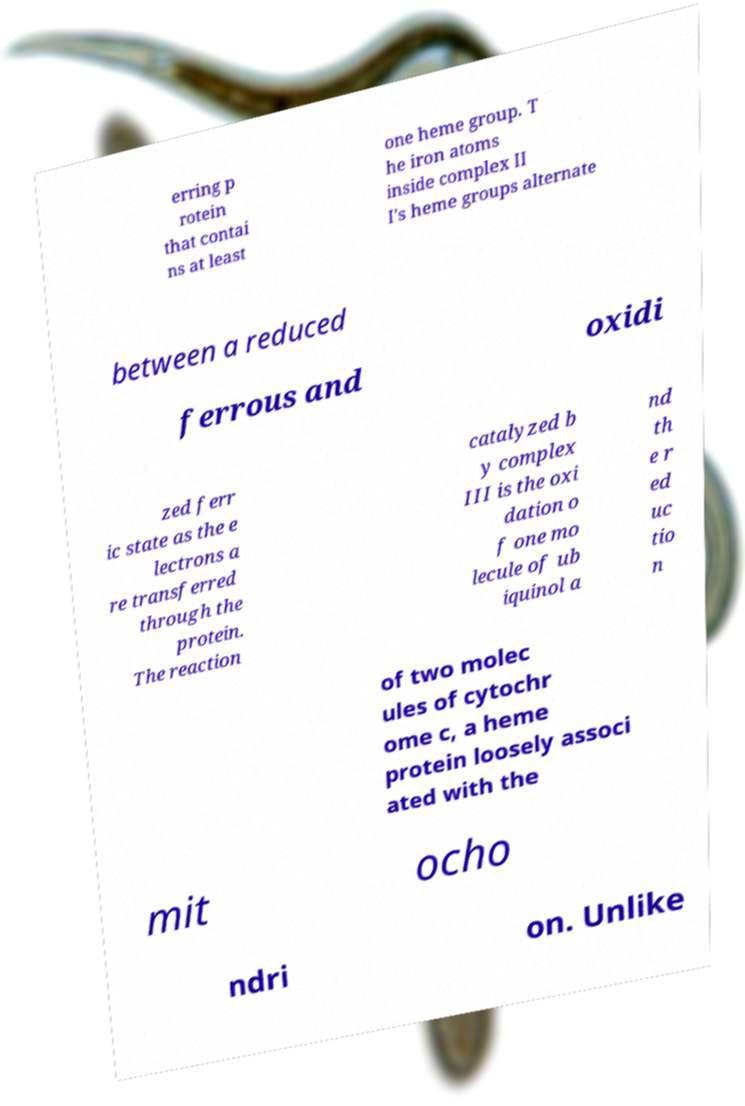Could you assist in decoding the text presented in this image and type it out clearly? erring p rotein that contai ns at least one heme group. T he iron atoms inside complex II I's heme groups alternate between a reduced ferrous and oxidi zed ferr ic state as the e lectrons a re transferred through the protein. The reaction catalyzed b y complex III is the oxi dation o f one mo lecule of ub iquinol a nd th e r ed uc tio n of two molec ules of cytochr ome c, a heme protein loosely associ ated with the mit ocho ndri on. Unlike 